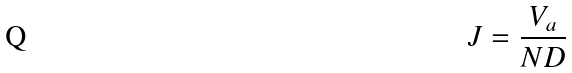Convert formula to latex. <formula><loc_0><loc_0><loc_500><loc_500>J = \frac { V _ { a } } { N D }</formula> 